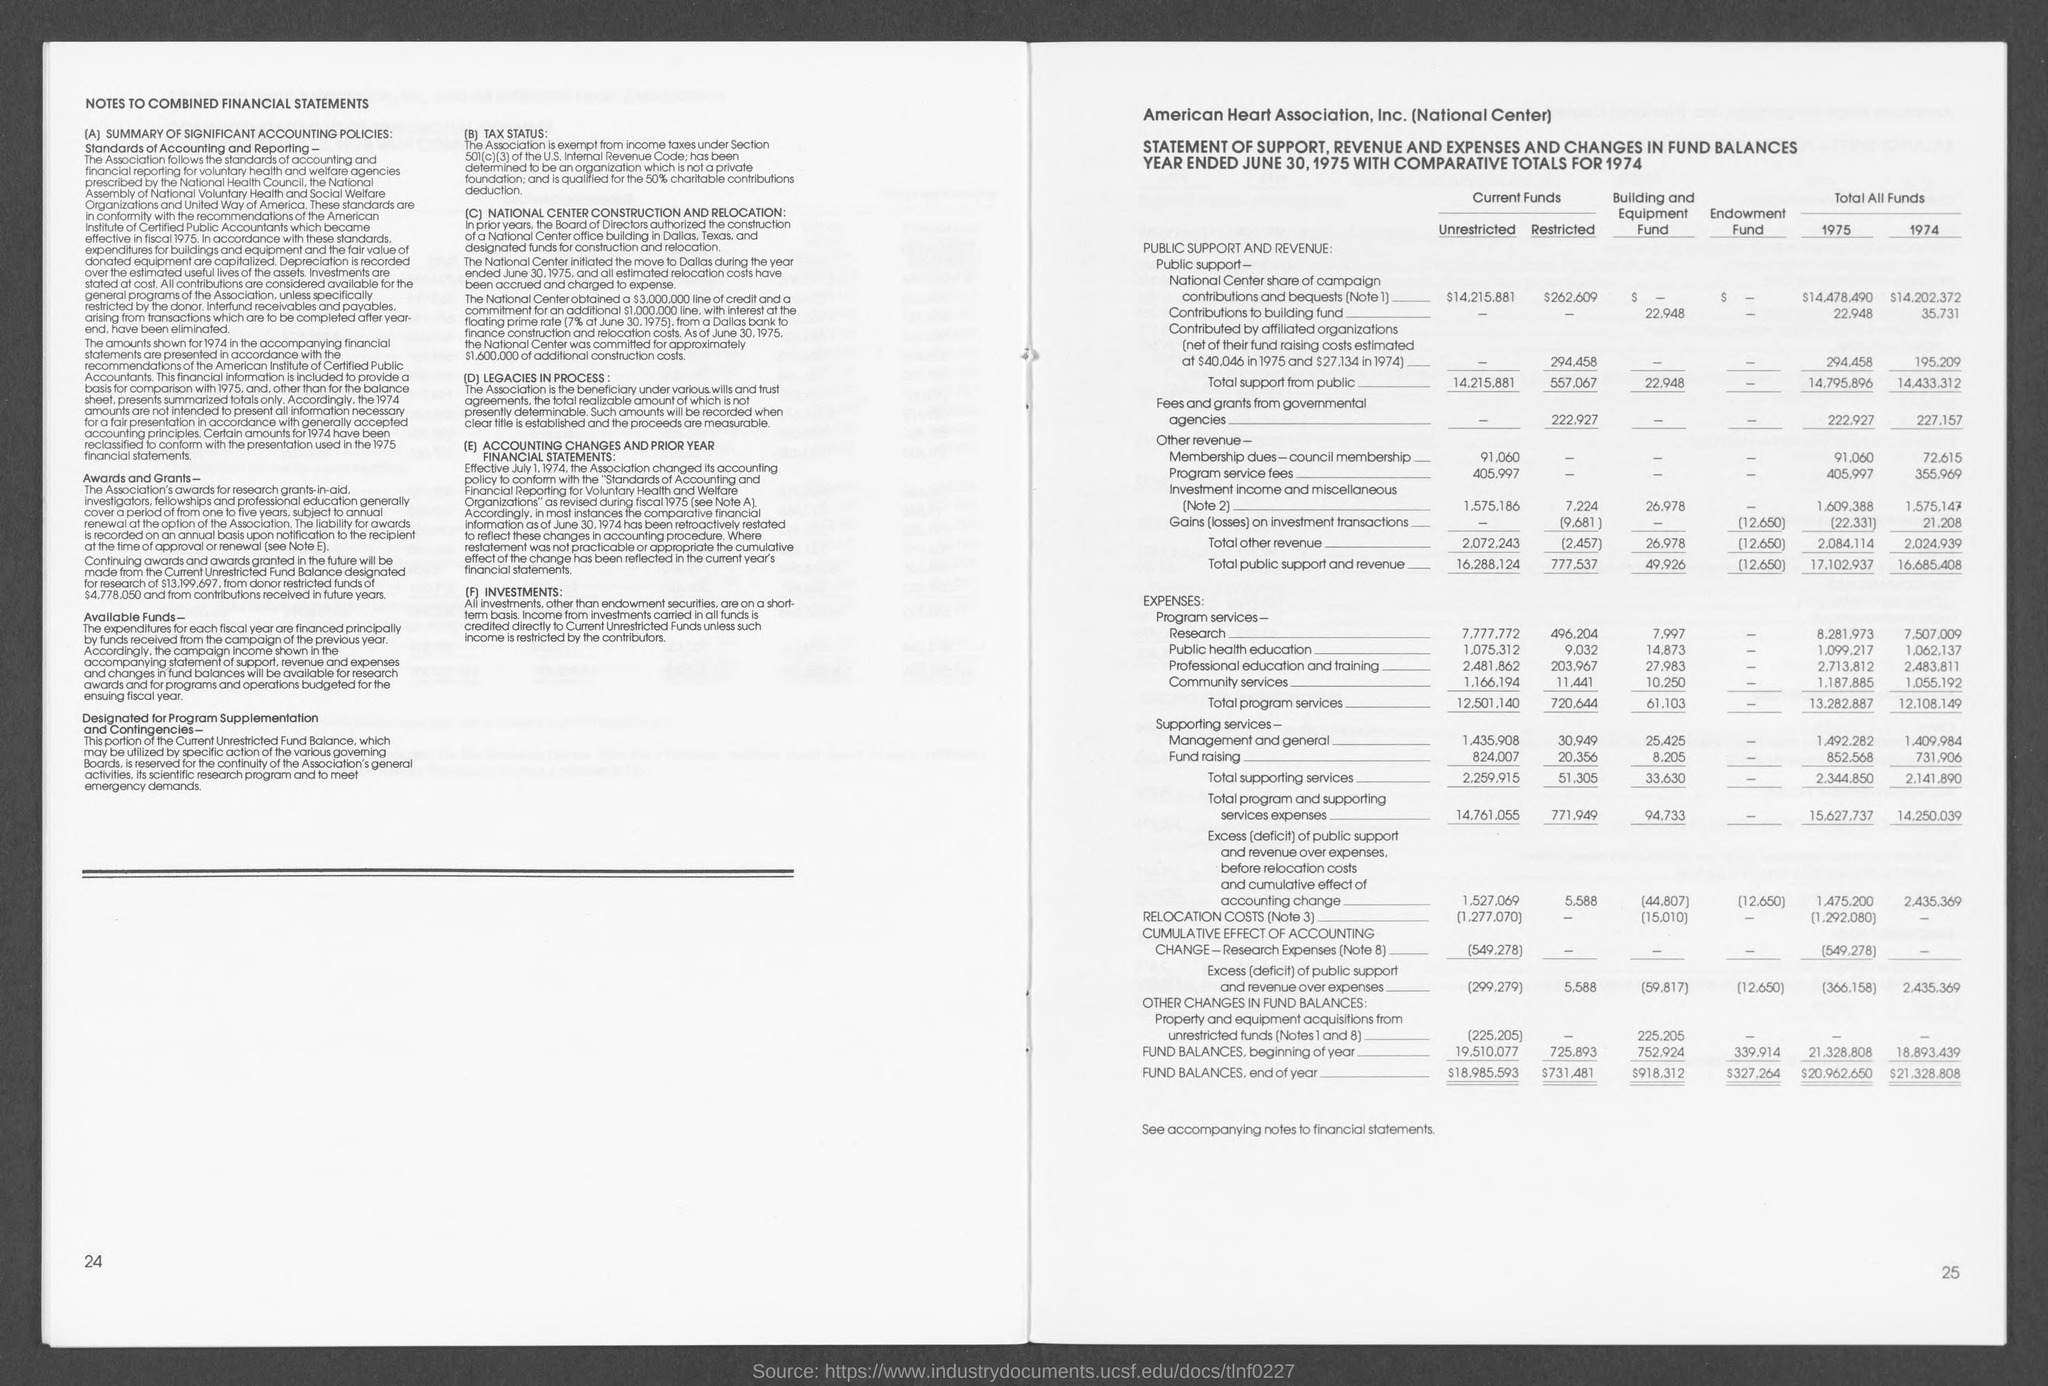Specify some key components in this picture. The unrestricted current funds had a fund balance of $18,985,593 at the end of the year. The fund balance for endowment funds at the end of the year is $327,264. The restricted current funds have a total of $731,481 in their fund balance as of the end of the year. The fund balance for the Building and Equipment Fund as of the end of the year is $918,312. 